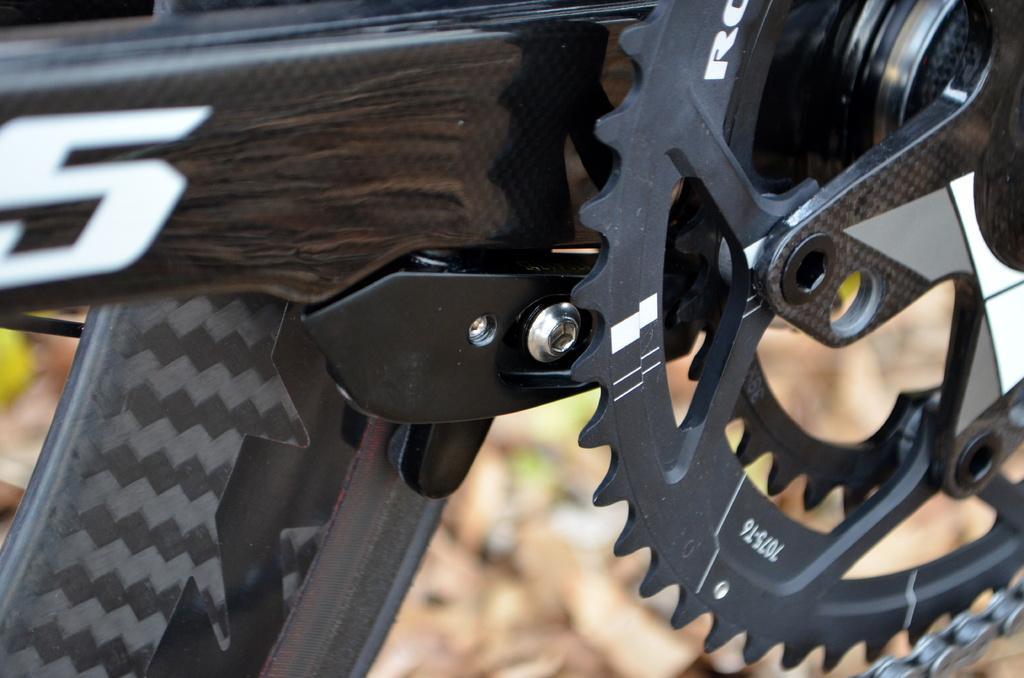Could you give a brief overview of what you see in this image? In this image there is a bicycle having a metal wheel which is having a chain. Background there is land. 